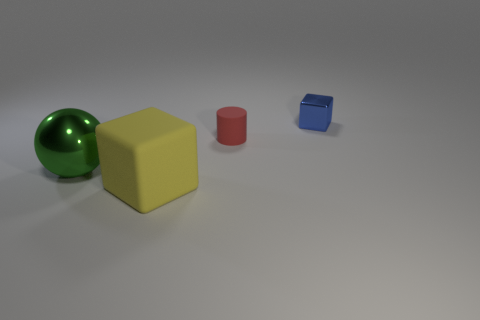Add 1 small purple shiny objects. How many objects exist? 5 Subtract all cylinders. How many objects are left? 3 Subtract 1 green spheres. How many objects are left? 3 Subtract all brown matte balls. Subtract all tiny cubes. How many objects are left? 3 Add 3 shiny spheres. How many shiny spheres are left? 4 Add 1 metallic things. How many metallic things exist? 3 